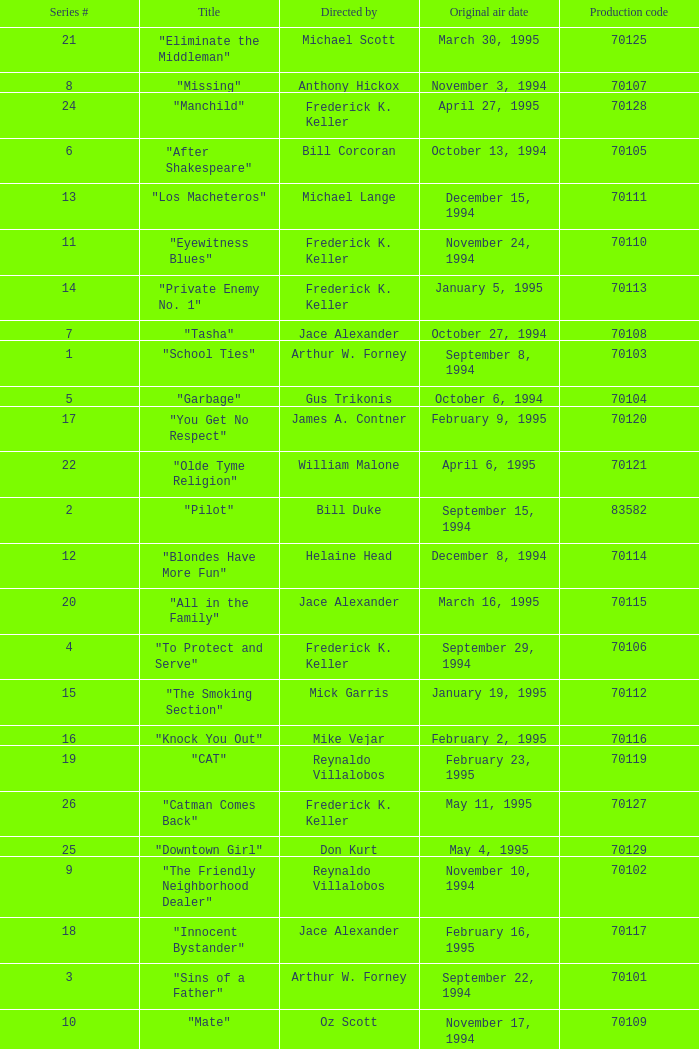What was the lowest production code value in series #10? 70109.0. 